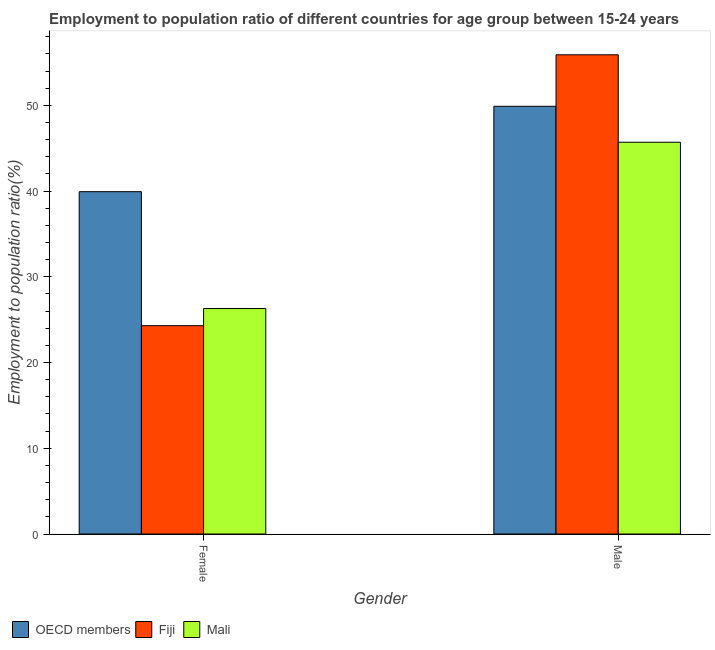How many different coloured bars are there?
Your answer should be compact. 3. How many groups of bars are there?
Provide a short and direct response. 2. Are the number of bars per tick equal to the number of legend labels?
Offer a very short reply. Yes. Are the number of bars on each tick of the X-axis equal?
Make the answer very short. Yes. How many bars are there on the 1st tick from the left?
Offer a very short reply. 3. What is the label of the 2nd group of bars from the left?
Provide a short and direct response. Male. What is the employment to population ratio(male) in Fiji?
Make the answer very short. 55.9. Across all countries, what is the maximum employment to population ratio(female)?
Offer a terse response. 39.93. Across all countries, what is the minimum employment to population ratio(male)?
Provide a succinct answer. 45.7. In which country was the employment to population ratio(male) maximum?
Offer a very short reply. Fiji. In which country was the employment to population ratio(male) minimum?
Ensure brevity in your answer.  Mali. What is the total employment to population ratio(female) in the graph?
Ensure brevity in your answer.  90.53. What is the difference between the employment to population ratio(male) in Mali and that in Fiji?
Your response must be concise. -10.2. What is the difference between the employment to population ratio(male) in Fiji and the employment to population ratio(female) in Mali?
Give a very brief answer. 29.6. What is the average employment to population ratio(male) per country?
Give a very brief answer. 50.5. What is the difference between the employment to population ratio(female) and employment to population ratio(male) in Fiji?
Give a very brief answer. -31.6. In how many countries, is the employment to population ratio(female) greater than 22 %?
Your answer should be very brief. 3. What is the ratio of the employment to population ratio(male) in Mali to that in OECD members?
Provide a succinct answer. 0.92. In how many countries, is the employment to population ratio(male) greater than the average employment to population ratio(male) taken over all countries?
Give a very brief answer. 1. What does the 1st bar from the left in Female represents?
Provide a short and direct response. OECD members. What does the 1st bar from the right in Female represents?
Provide a short and direct response. Mali. How many countries are there in the graph?
Your response must be concise. 3. Are the values on the major ticks of Y-axis written in scientific E-notation?
Your response must be concise. No. What is the title of the graph?
Ensure brevity in your answer.  Employment to population ratio of different countries for age group between 15-24 years. Does "India" appear as one of the legend labels in the graph?
Make the answer very short. No. What is the label or title of the X-axis?
Offer a terse response. Gender. What is the Employment to population ratio(%) of OECD members in Female?
Your answer should be very brief. 39.93. What is the Employment to population ratio(%) of Fiji in Female?
Offer a very short reply. 24.3. What is the Employment to population ratio(%) in Mali in Female?
Your answer should be compact. 26.3. What is the Employment to population ratio(%) of OECD members in Male?
Give a very brief answer. 49.89. What is the Employment to population ratio(%) in Fiji in Male?
Your response must be concise. 55.9. What is the Employment to population ratio(%) in Mali in Male?
Give a very brief answer. 45.7. Across all Gender, what is the maximum Employment to population ratio(%) in OECD members?
Your answer should be compact. 49.89. Across all Gender, what is the maximum Employment to population ratio(%) of Fiji?
Ensure brevity in your answer.  55.9. Across all Gender, what is the maximum Employment to population ratio(%) in Mali?
Give a very brief answer. 45.7. Across all Gender, what is the minimum Employment to population ratio(%) in OECD members?
Offer a very short reply. 39.93. Across all Gender, what is the minimum Employment to population ratio(%) of Fiji?
Give a very brief answer. 24.3. Across all Gender, what is the minimum Employment to population ratio(%) of Mali?
Keep it short and to the point. 26.3. What is the total Employment to population ratio(%) of OECD members in the graph?
Your response must be concise. 89.82. What is the total Employment to population ratio(%) of Fiji in the graph?
Your answer should be very brief. 80.2. What is the total Employment to population ratio(%) in Mali in the graph?
Offer a very short reply. 72. What is the difference between the Employment to population ratio(%) in OECD members in Female and that in Male?
Your answer should be very brief. -9.96. What is the difference between the Employment to population ratio(%) in Fiji in Female and that in Male?
Ensure brevity in your answer.  -31.6. What is the difference between the Employment to population ratio(%) in Mali in Female and that in Male?
Your response must be concise. -19.4. What is the difference between the Employment to population ratio(%) in OECD members in Female and the Employment to population ratio(%) in Fiji in Male?
Your response must be concise. -15.97. What is the difference between the Employment to population ratio(%) of OECD members in Female and the Employment to population ratio(%) of Mali in Male?
Offer a terse response. -5.77. What is the difference between the Employment to population ratio(%) of Fiji in Female and the Employment to population ratio(%) of Mali in Male?
Offer a terse response. -21.4. What is the average Employment to population ratio(%) of OECD members per Gender?
Your response must be concise. 44.91. What is the average Employment to population ratio(%) of Fiji per Gender?
Keep it short and to the point. 40.1. What is the difference between the Employment to population ratio(%) of OECD members and Employment to population ratio(%) of Fiji in Female?
Make the answer very short. 15.63. What is the difference between the Employment to population ratio(%) in OECD members and Employment to population ratio(%) in Mali in Female?
Provide a short and direct response. 13.63. What is the difference between the Employment to population ratio(%) of Fiji and Employment to population ratio(%) of Mali in Female?
Provide a succinct answer. -2. What is the difference between the Employment to population ratio(%) of OECD members and Employment to population ratio(%) of Fiji in Male?
Offer a very short reply. -6.01. What is the difference between the Employment to population ratio(%) of OECD members and Employment to population ratio(%) of Mali in Male?
Offer a very short reply. 4.19. What is the difference between the Employment to population ratio(%) in Fiji and Employment to population ratio(%) in Mali in Male?
Your answer should be compact. 10.2. What is the ratio of the Employment to population ratio(%) of OECD members in Female to that in Male?
Your answer should be very brief. 0.8. What is the ratio of the Employment to population ratio(%) in Fiji in Female to that in Male?
Your response must be concise. 0.43. What is the ratio of the Employment to population ratio(%) of Mali in Female to that in Male?
Your answer should be compact. 0.58. What is the difference between the highest and the second highest Employment to population ratio(%) in OECD members?
Your answer should be very brief. 9.96. What is the difference between the highest and the second highest Employment to population ratio(%) in Fiji?
Provide a succinct answer. 31.6. What is the difference between the highest and the second highest Employment to population ratio(%) in Mali?
Your answer should be compact. 19.4. What is the difference between the highest and the lowest Employment to population ratio(%) of OECD members?
Your answer should be very brief. 9.96. What is the difference between the highest and the lowest Employment to population ratio(%) of Fiji?
Give a very brief answer. 31.6. 